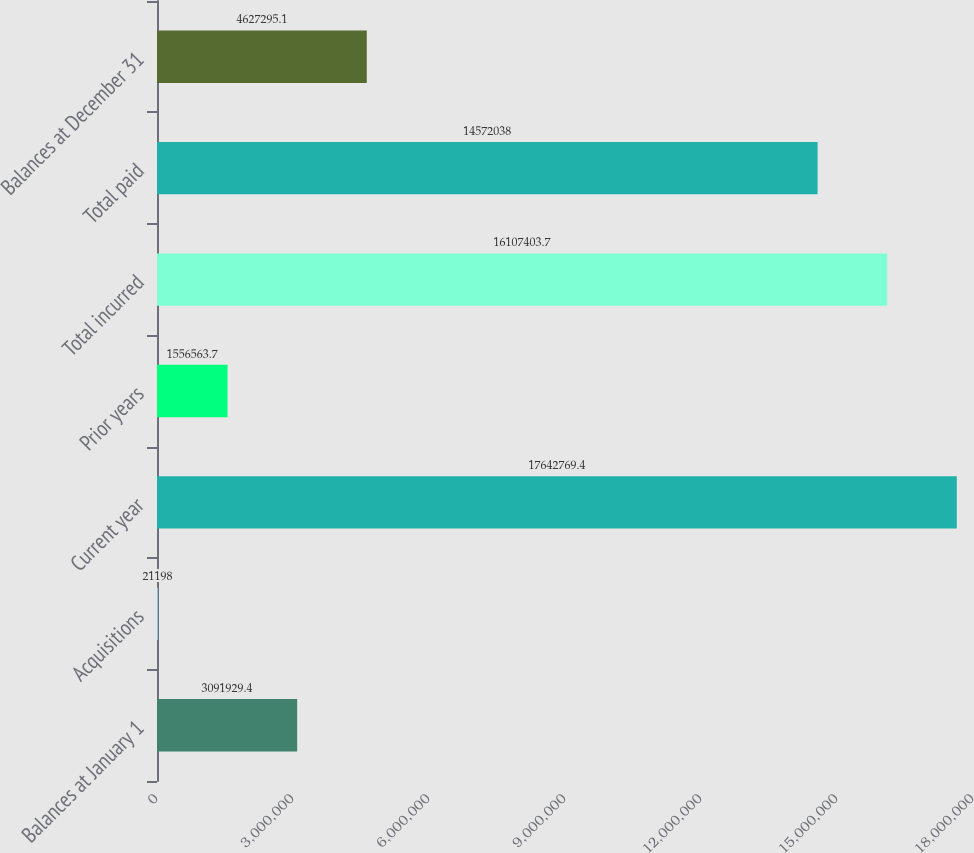<chart> <loc_0><loc_0><loc_500><loc_500><bar_chart><fcel>Balances at January 1<fcel>Acquisitions<fcel>Current year<fcel>Prior years<fcel>Total incurred<fcel>Total paid<fcel>Balances at December 31<nl><fcel>3.09193e+06<fcel>21198<fcel>1.76428e+07<fcel>1.55656e+06<fcel>1.61074e+07<fcel>1.4572e+07<fcel>4.6273e+06<nl></chart> 